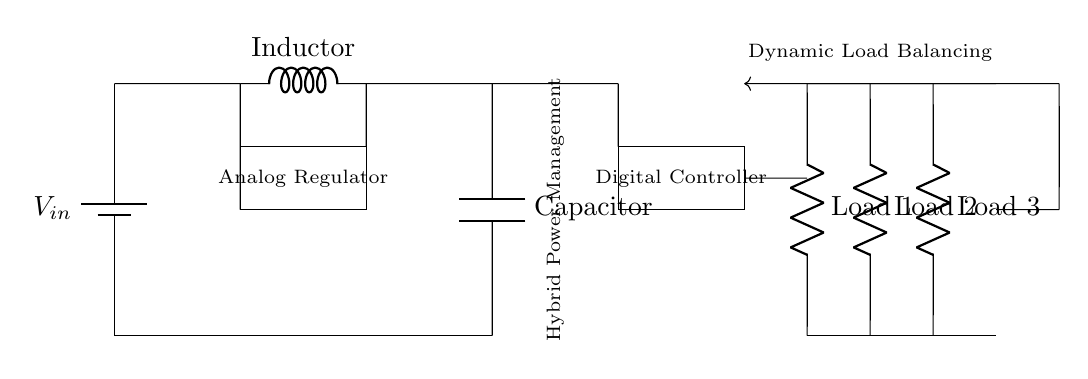What type of regulator is shown in the circuit? The circuit contains an analog voltage regulator, which is clearly labeled in the box between the components.
Answer: Analog Regulator How many loads are connected in this circuit? The circuit diagram shows three distinct resistive loads (Load 1, Load 2, and Load 3) connected to the power management system.
Answer: Three What is the purpose of the digital controller? The digital controller manages the load balancing by dynamically adjusting power distribution to the various loads based on requirements, as indicated by its label in the diagram.
Answer: Dynamic Load Balancing What component is used to store energy in the circuit? The circuit has a capacitor that stores energy, which is visibly represented in the lower section of the circuit below the analog regulator.
Answer: Capacitor What is the function of the inductor in this circuit? The inductor in the circuit serves to filter and smooth the input voltage by resisting changes in current, as seen in its placement in series with the voltage source.
Answer: Filter Explain how feedback is utilized in this system. Feedback is shown with an arrow pointing from a junction to the digital controller, indicating that the output or performance of the system is monitored and adjusted based on feedback conditions for optimal management.
Answer: Adjust power dynamically 